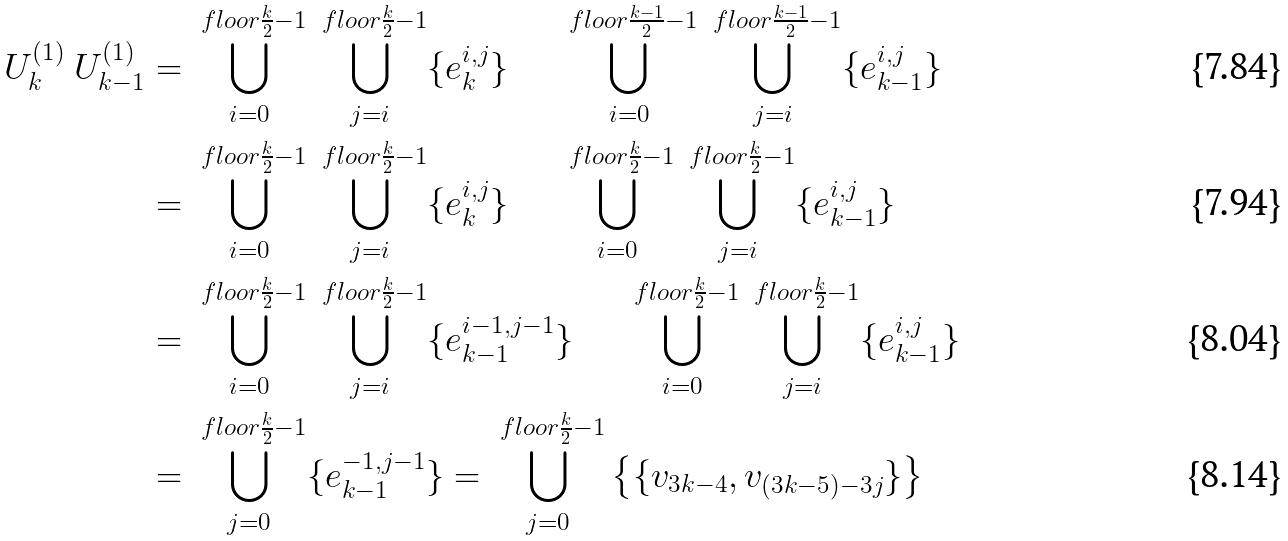<formula> <loc_0><loc_0><loc_500><loc_500>U _ { k } ^ { ( 1 ) } \ U _ { k - 1 } ^ { ( 1 ) } & = \bigcup _ { i = 0 } ^ { \ f l o o r { \frac { k } { 2 } } - 1 } \bigcup _ { j = i } ^ { \ f l o o r { \frac { k } { 2 } } - 1 } \{ e _ { k } ^ { i , j } \} \quad \ \bigcup _ { i = 0 } ^ { \ f l o o r { \frac { k - 1 } { 2 } } - 1 } \bigcup _ { j = i } ^ { \ f l o o r { \frac { k - 1 } { 2 } } - 1 } \{ e _ { k - 1 } ^ { i , j } \} \\ & = \bigcup _ { i = 0 } ^ { \ f l o o r { \frac { k } { 2 } } - 1 } \bigcup _ { j = i } ^ { \ f l o o r { \frac { k } { 2 } } - 1 } \{ e _ { k } ^ { i , j } \} \quad \ \bigcup _ { i = 0 } ^ { \ f l o o r { \frac { k } { 2 } } - 1 } \bigcup _ { j = i } ^ { \ f l o o r { \frac { k } { 2 } } - 1 } \{ e _ { k - 1 } ^ { i , j } \} \\ & = \bigcup _ { i = 0 } ^ { \ f l o o r { \frac { k } { 2 } } - 1 } \bigcup _ { j = i } ^ { \ f l o o r { \frac { k } { 2 } } - 1 } \{ e _ { k - 1 } ^ { i - 1 , j - 1 } \} \quad \ \bigcup _ { i = 0 } ^ { \ f l o o r { \frac { k } { 2 } } - 1 } \bigcup _ { j = i } ^ { \ f l o o r { \frac { k } { 2 } } - 1 } \{ e _ { k - 1 } ^ { i , j } \} \\ & = \bigcup _ { j = 0 } ^ { \ f l o o r { \frac { k } { 2 } } - 1 } \{ e _ { k - 1 } ^ { - 1 , j - 1 } \} = \bigcup _ { j = 0 } ^ { \ f l o o r { \frac { k } { 2 } } - 1 } \left \{ \{ v _ { 3 k - 4 } , v _ { ( 3 k - 5 ) - 3 j } \} \right \}</formula> 